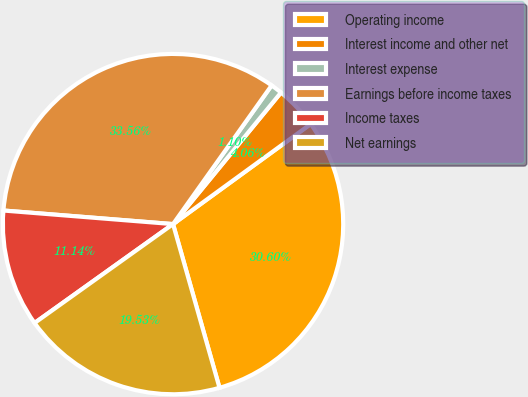Convert chart to OTSL. <chart><loc_0><loc_0><loc_500><loc_500><pie_chart><fcel>Operating income<fcel>Interest income and other net<fcel>Interest expense<fcel>Earnings before income taxes<fcel>Income taxes<fcel>Net earnings<nl><fcel>30.6%<fcel>4.06%<fcel>1.1%<fcel>33.56%<fcel>11.14%<fcel>19.53%<nl></chart> 